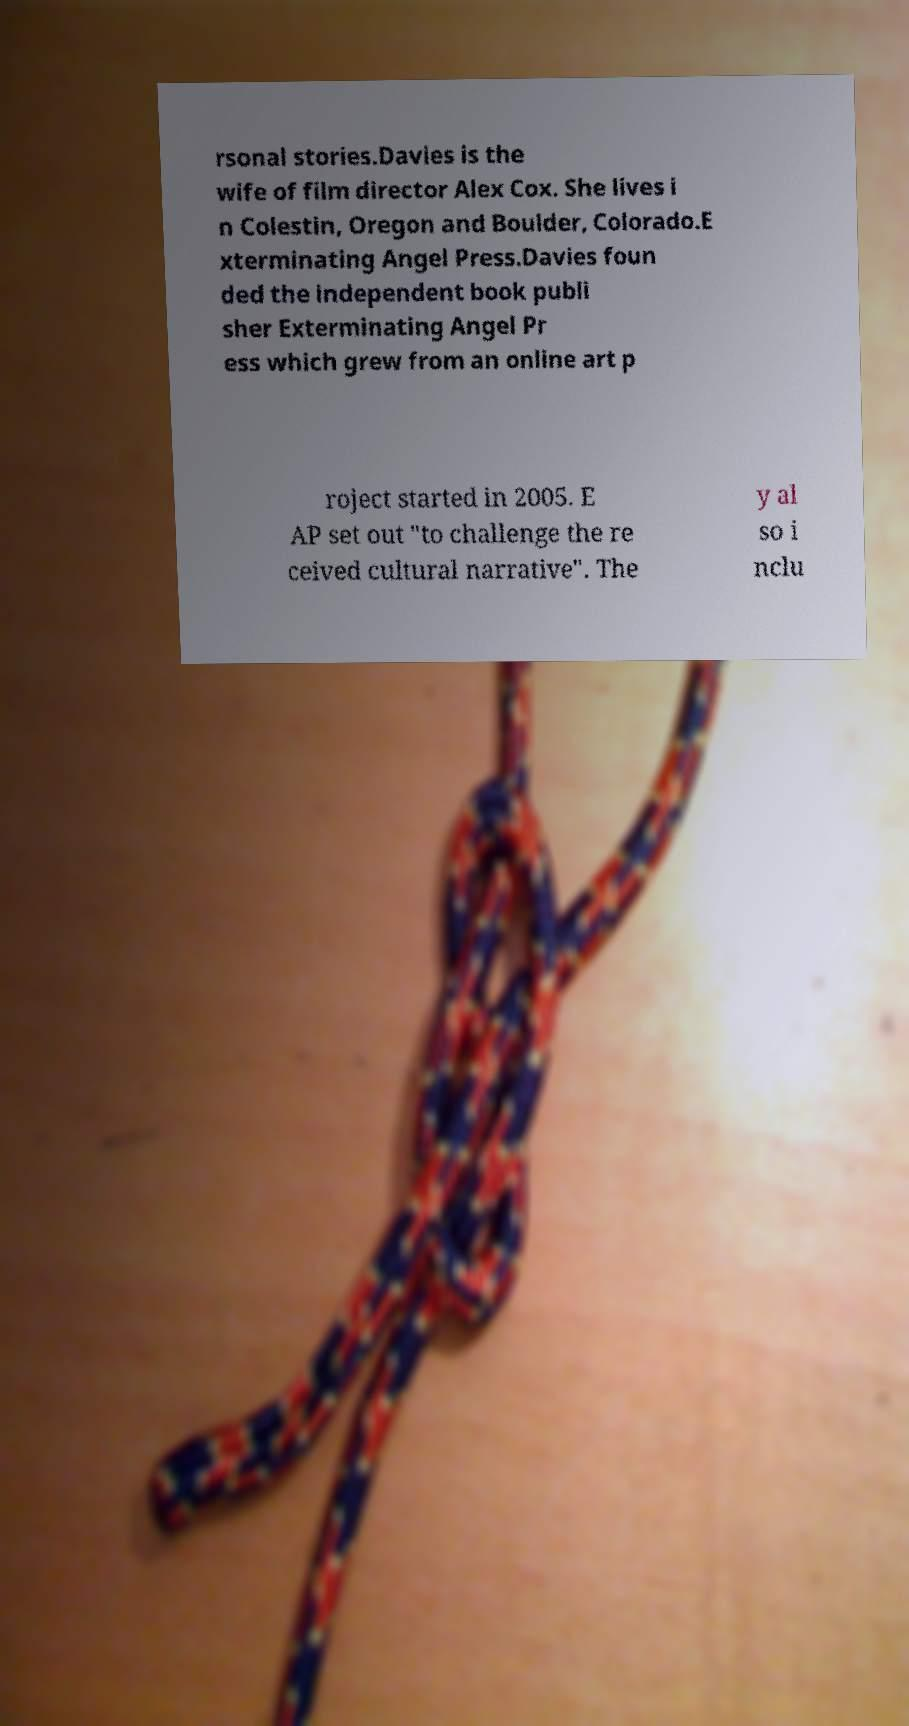Can you read and provide the text displayed in the image?This photo seems to have some interesting text. Can you extract and type it out for me? rsonal stories.Davies is the wife of film director Alex Cox. She lives i n Colestin, Oregon and Boulder, Colorado.E xterminating Angel Press.Davies foun ded the independent book publi sher Exterminating Angel Pr ess which grew from an online art p roject started in 2005. E AP set out "to challenge the re ceived cultural narrative". The y al so i nclu 